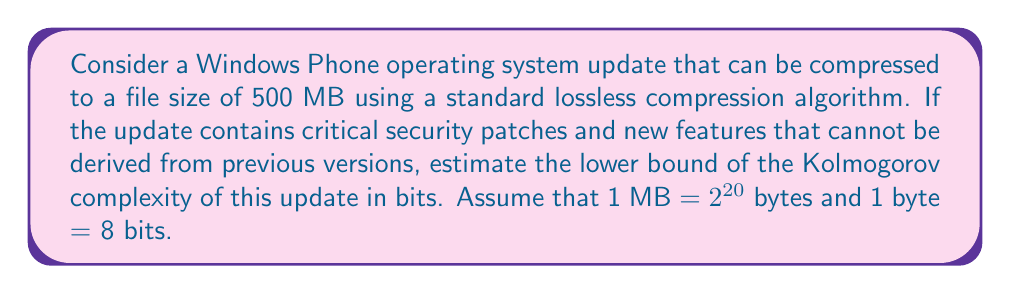What is the answer to this math problem? To estimate the lower bound of the Kolmogorov complexity of the Windows Phone operating system update, we need to consider the following steps:

1. Understand Kolmogorov complexity:
   Kolmogorov complexity $K(x)$ of an object $x$ is the length of the shortest program that produces $x$ as its output.

2. Relate compressed file size to Kolmogorov complexity:
   The compressed file size provides an upper bound for the Kolmogorov complexity. However, since the update contains critical security patches and new features that cannot be derived from previous versions, we can assume that the Kolmogorov complexity is close to this upper bound.

3. Convert file size to bits:
   Given: 
   - Compressed file size = 500 MB
   - 1 MB = $2^{20}$ bytes
   - 1 byte = 8 bits

   Calculation:
   $$\text{Size in bits} = 500 \times 2^{20} \times 8 = 500 \times 2^{23} \text{ bits}$$

4. Estimate lower bound:
   Since the update contains critical and non-derivable information, we can estimate the lower bound of Kolmogorov complexity to be very close to the compressed file size. Let's assume it's at least 99% of the compressed size:

   $$K(\text{update}) \geq 0.99 \times 500 \times 2^{23} \text{ bits}$$

5. Simplify the expression:
   $$K(\text{update}) \geq 495 \times 2^{23} \text{ bits}$$
Answer: The estimated lower bound of the Kolmogorov complexity of the Windows Phone operating system update is $495 \times 2^{23}$ bits. 